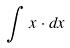Convert formula to latex. <formula><loc_0><loc_0><loc_500><loc_500>\int x \cdot d x</formula> 